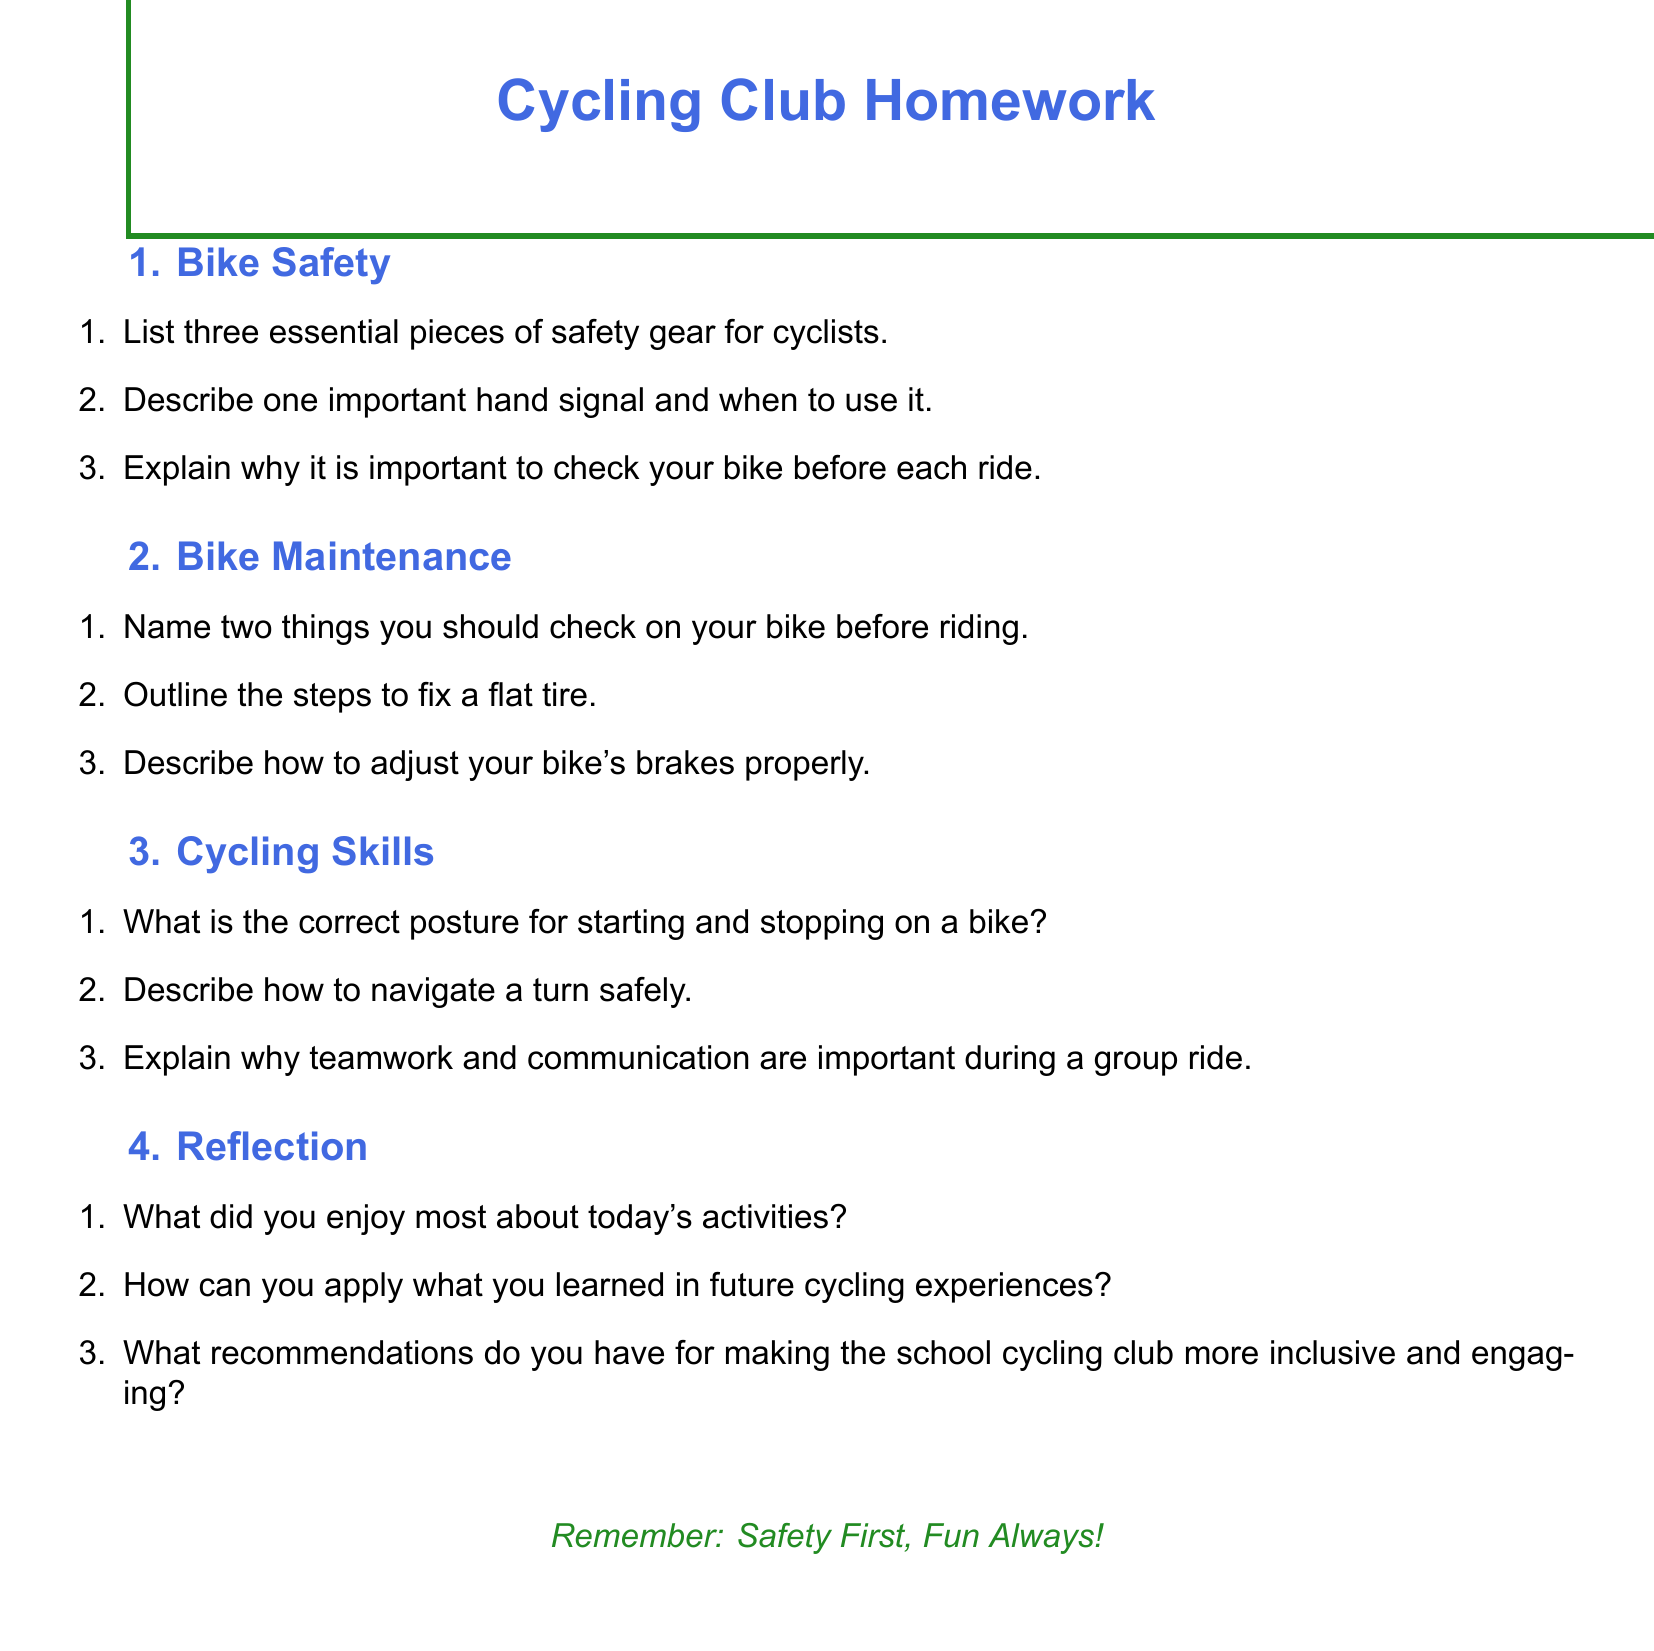What are three essential pieces of safety gear for cyclists? The document lists safety gear for cyclists in the section titled "Bike Safety".
Answer: Three What is one important hand signal mentioned in the document? The document requests the description of a hand signal in the "Bike Safety" section.
Answer: Important hand signal How many steps are outlined to fix a flat tire? The number of steps for fixing a flat tire is asked in the "Bike Maintenance" section.
Answer: Steps What should you check on your bike before riding? The document lists items to check in the "Bike Maintenance" section.
Answer: Two What is emphasized in the document about future cycling experiences? A question in the "Reflection" section discusses applying learned information in future cycling experiences.
Answer: Apply What is mentioned about teamwork and communication? The importance of teamwork and communication during a group ride is explained in the "Cycling Skills" section.
Answer: Important How can the school cycling club be made more inclusive? The document asks for recommendations about inclusivity in the "Reflection" section.
Answer: More inclusive What do the colors of the document represent? The document features colors specific to cycling clubs, indicating their importance in the theme.
Answer: Cycleblue and cyclegreen How should one navigate a turn safely? The document addresses navigating turns in the "Cycling Skills" section, which is a skill discussed.
Answer: Navigate safely 